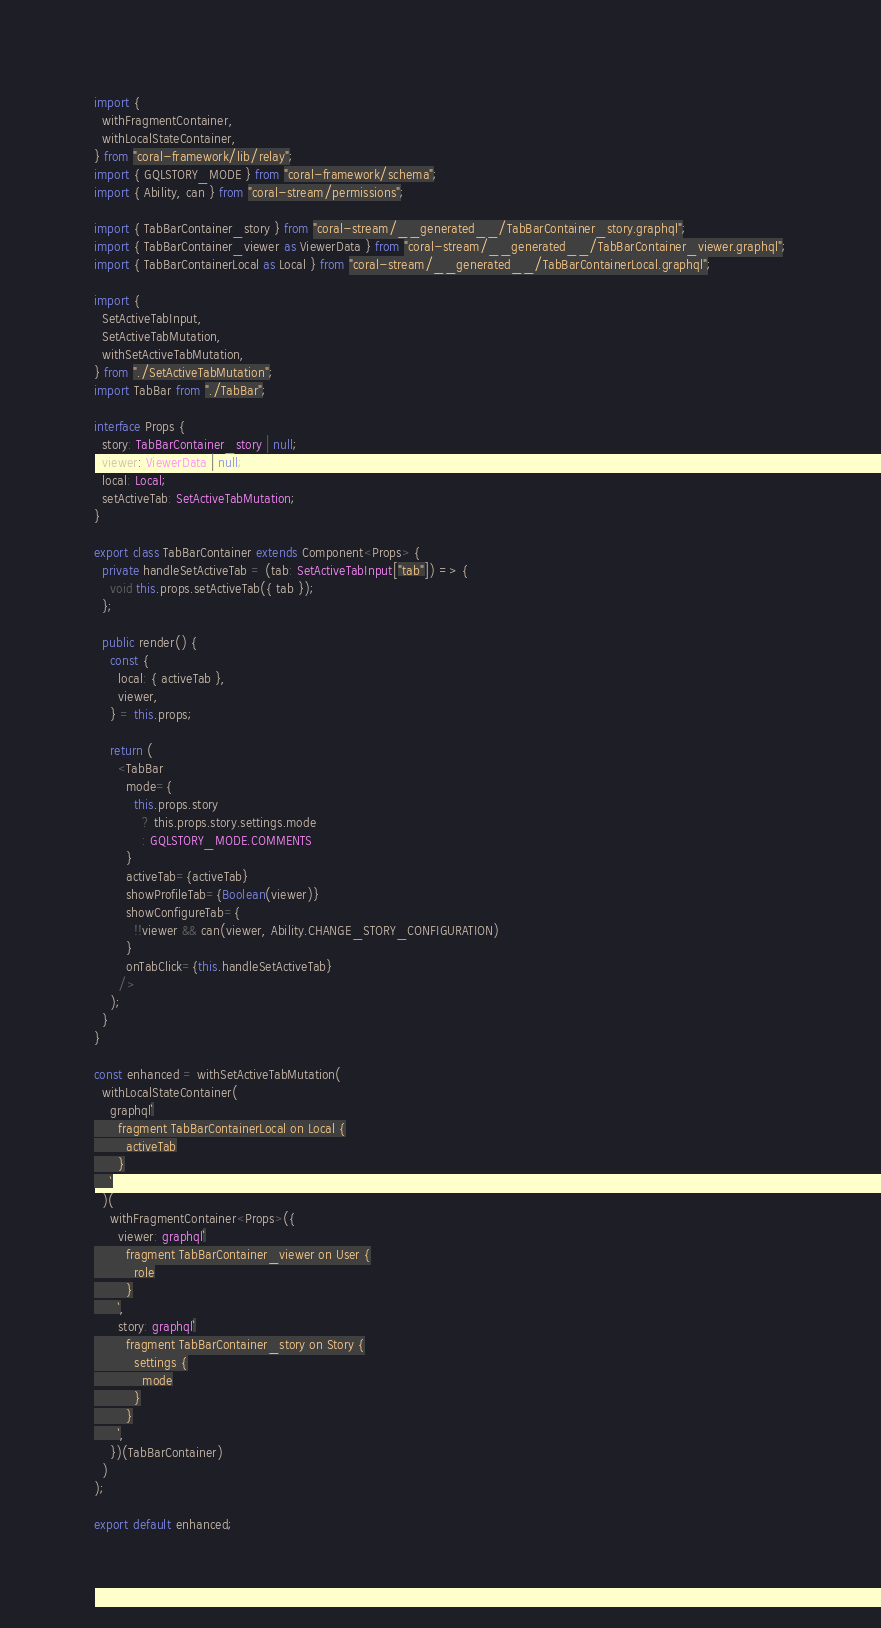<code> <loc_0><loc_0><loc_500><loc_500><_TypeScript_>
import {
  withFragmentContainer,
  withLocalStateContainer,
} from "coral-framework/lib/relay";
import { GQLSTORY_MODE } from "coral-framework/schema";
import { Ability, can } from "coral-stream/permissions";

import { TabBarContainer_story } from "coral-stream/__generated__/TabBarContainer_story.graphql";
import { TabBarContainer_viewer as ViewerData } from "coral-stream/__generated__/TabBarContainer_viewer.graphql";
import { TabBarContainerLocal as Local } from "coral-stream/__generated__/TabBarContainerLocal.graphql";

import {
  SetActiveTabInput,
  SetActiveTabMutation,
  withSetActiveTabMutation,
} from "./SetActiveTabMutation";
import TabBar from "./TabBar";

interface Props {
  story: TabBarContainer_story | null;
  viewer: ViewerData | null;
  local: Local;
  setActiveTab: SetActiveTabMutation;
}

export class TabBarContainer extends Component<Props> {
  private handleSetActiveTab = (tab: SetActiveTabInput["tab"]) => {
    void this.props.setActiveTab({ tab });
  };

  public render() {
    const {
      local: { activeTab },
      viewer,
    } = this.props;

    return (
      <TabBar
        mode={
          this.props.story
            ? this.props.story.settings.mode
            : GQLSTORY_MODE.COMMENTS
        }
        activeTab={activeTab}
        showProfileTab={Boolean(viewer)}
        showConfigureTab={
          !!viewer && can(viewer, Ability.CHANGE_STORY_CONFIGURATION)
        }
        onTabClick={this.handleSetActiveTab}
      />
    );
  }
}

const enhanced = withSetActiveTabMutation(
  withLocalStateContainer(
    graphql`
      fragment TabBarContainerLocal on Local {
        activeTab
      }
    `
  )(
    withFragmentContainer<Props>({
      viewer: graphql`
        fragment TabBarContainer_viewer on User {
          role
        }
      `,
      story: graphql`
        fragment TabBarContainer_story on Story {
          settings {
            mode
          }
        }
      `,
    })(TabBarContainer)
  )
);

export default enhanced;
</code> 